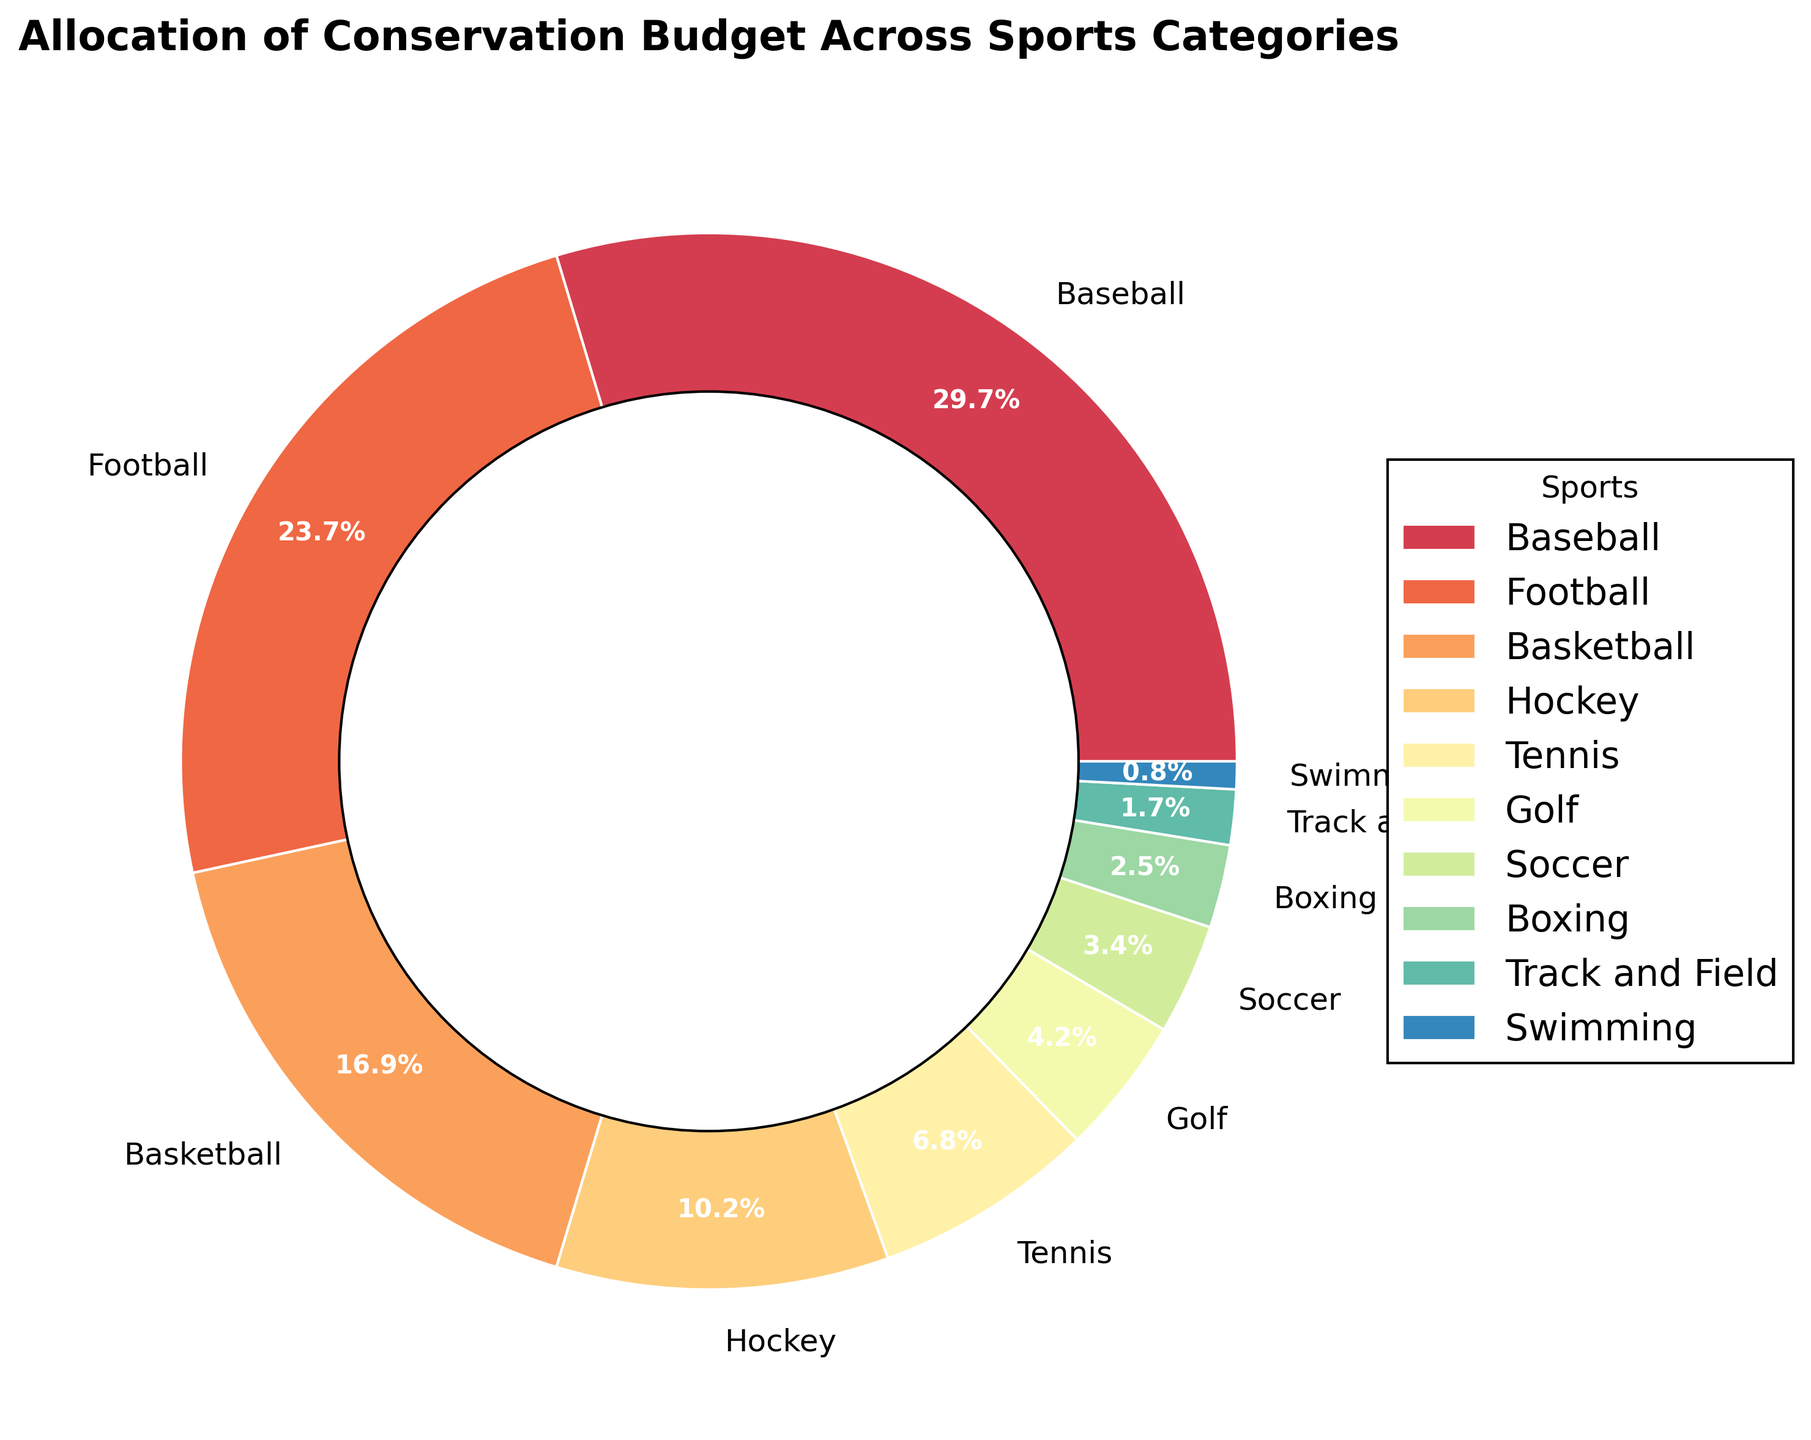What's the sport with the highest budget allocation? Looking at the pie chart, the largest section corresponds to the sport with the highest budget allocation, which is Baseball.
Answer: Baseball What is the combined budget allocation for Hockey and Tennis? To find this, sum the allocations for Hockey (12) and Tennis (8), which is 12 + 8 = 20.
Answer: 20 How much more budget allocation does Basketball have compared to Soccer? Basketball has a budget allocation of 20, whereas Soccer has 4. Subtract the smaller from the larger amount: 20 - 4 = 16.
Answer: 16 Which sport has a slightly higher budget allocation, Golf or Soccer? By comparing the slices for Golf (5) and Soccer (4), it is clear that Golf has a slightly higher budget allocation.
Answer: Golf What percentage of the total budget is allocated to sports other than Baseball and Football? First, find the individual allocations for Baseball (35) and Football (28) and sum them: 35 + 28 = 63. The total allocation is 100. Subtract the sum from the total: 100 - 63 = 37%.
Answer: 37% What is the combined budget allocation for the three sports with the lowest budget allocations? The budgets for the three sports with the lowest allocations are Swimming (1), Track and Field (2), and Boxing (3). Sum them up: 1 + 2 + 3 = 6.
Answer: 6 Which sport's budget allocation is closest to 10% of the total budget? Tennis has an 8% allocation; Hockey has a 12% allocation. Tennis is closest to 10%.
Answer: Tennis How much more is the budget allocated to Baseball compared to all the sports with allocations less than 10% (Tennis, Golf, Soccer, Boxing, Track and Field, Swimming) combined? Summing the budget for Tennis (8), Golf (5), Soccer (4), Boxing (3), Track and Field (2), and Swimming (1) gives 23. Baseball’s allocation is 35. The difference is 35 - 23 = 12.
Answer: 12 What sports have a greater budget allocation than Hockey? The sports with greater allocations than Hockey (12%) are Baseball (35%), Football (28%), and Basketball (20%).
Answer: Baseball, Football, Basketball Which category has the smallest budget allocation and what percentage is it? Swimming has the smallest budget allocation, which is visible as the smallest slice in the pie chart, and it's labeled as 1%.
Answer: Swimming, 1% 